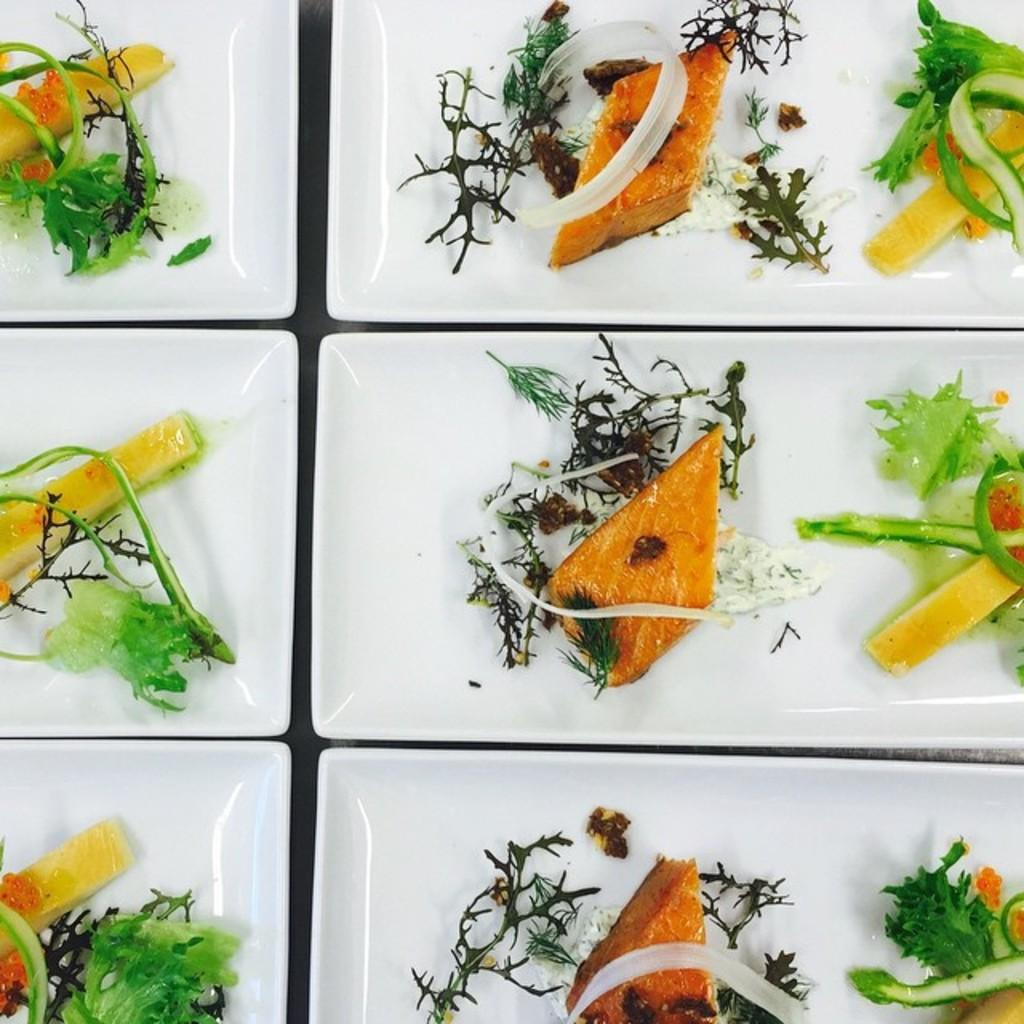What type of plates are the food items placed on in the image? The food items are placed on white plates in the image. Can you describe the food items on the plates? Unfortunately, the facts provided do not specify the type of food items on the plates. What type of winter clothing is visible on the plates in the image? There is no winter clothing present on the plates in the image; the plates contain food items. Is there a line of agreement drawn on the plates in the image? There is no line or any other markings visible on the plates in the image. 